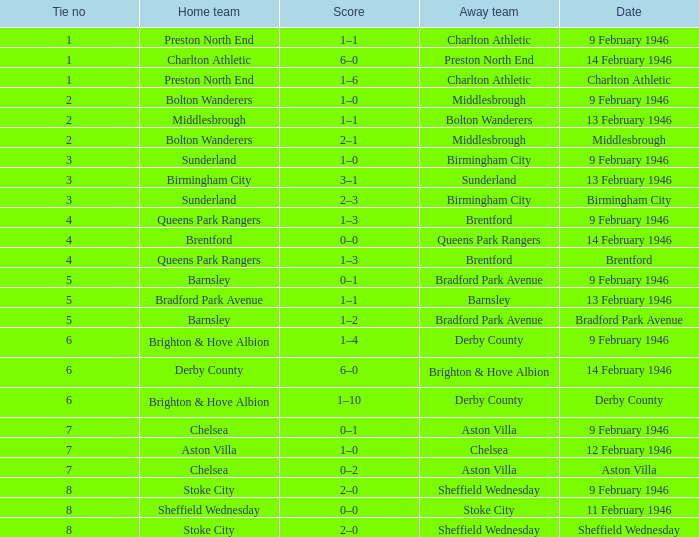What was the highest Tie no when the home team was the Bolton Wanderers, and the date was Middlesbrough? 2.0. 